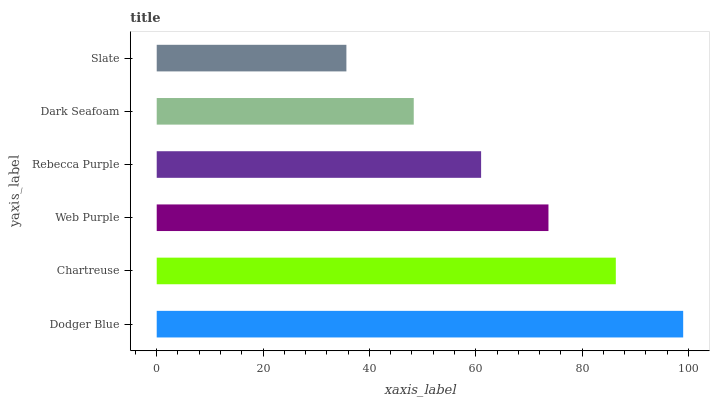Is Slate the minimum?
Answer yes or no. Yes. Is Dodger Blue the maximum?
Answer yes or no. Yes. Is Chartreuse the minimum?
Answer yes or no. No. Is Chartreuse the maximum?
Answer yes or no. No. Is Dodger Blue greater than Chartreuse?
Answer yes or no. Yes. Is Chartreuse less than Dodger Blue?
Answer yes or no. Yes. Is Chartreuse greater than Dodger Blue?
Answer yes or no. No. Is Dodger Blue less than Chartreuse?
Answer yes or no. No. Is Web Purple the high median?
Answer yes or no. Yes. Is Rebecca Purple the low median?
Answer yes or no. Yes. Is Slate the high median?
Answer yes or no. No. Is Slate the low median?
Answer yes or no. No. 